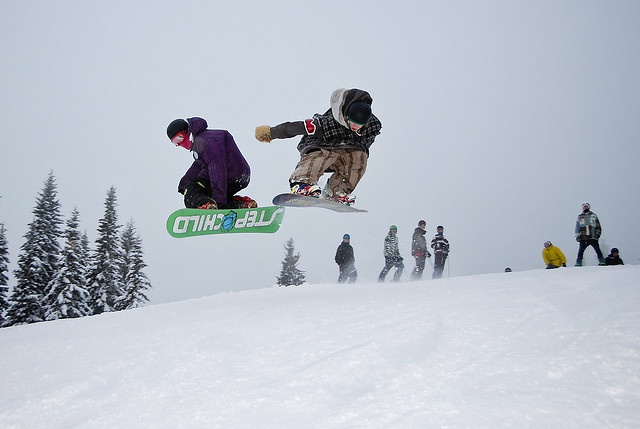Describe the objects in this image and their specific colors. I can see people in lightgray, black, gray, and darkgray tones, people in lightgray, black, navy, purple, and gray tones, snowboard in lightgray, green, darkgray, and teal tones, people in lightgray, black, gray, and darkgray tones, and people in lightgray, gray, and darkgray tones in this image. 